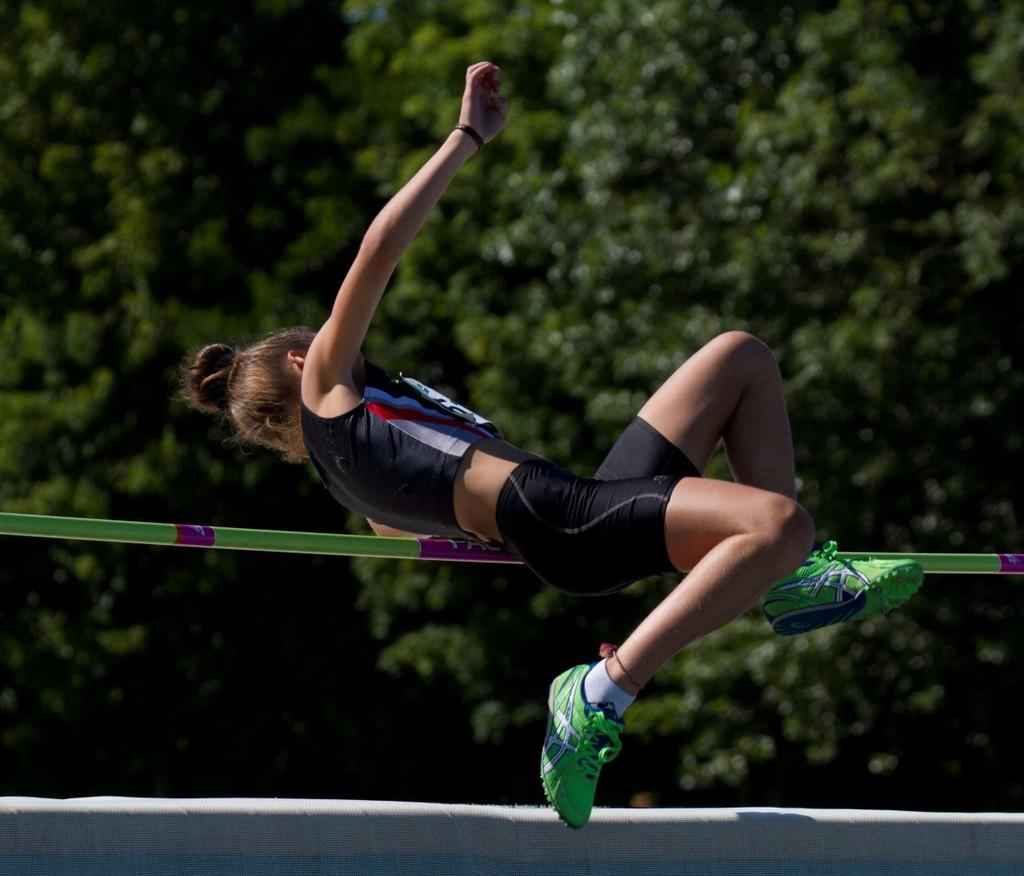What is located in the center of the image? There is a stick in the center of the image. What is the person in the image doing? A person is jumping in the image. What can be seen in the background of the image? There are trees in the background of the image. What is at the bottom of the image? There is a board at the bottom of the image. What type of mint is growing on the stick in the image? There is no mint present in the image; it features a stick and a person jumping. What impulse might have caused the person to jump in the image? The image does not provide information about the person's motivation for jumping, so it cannot be determined from the image. 